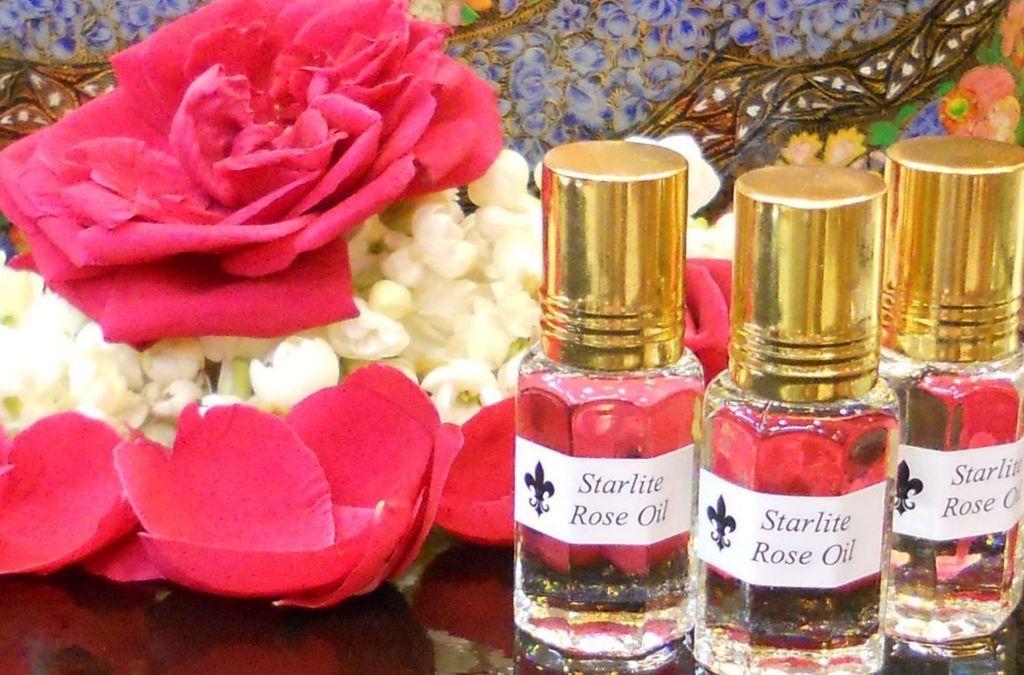Please provide a concise description of this image. In this picture we can see couple of bottles and flowers. 